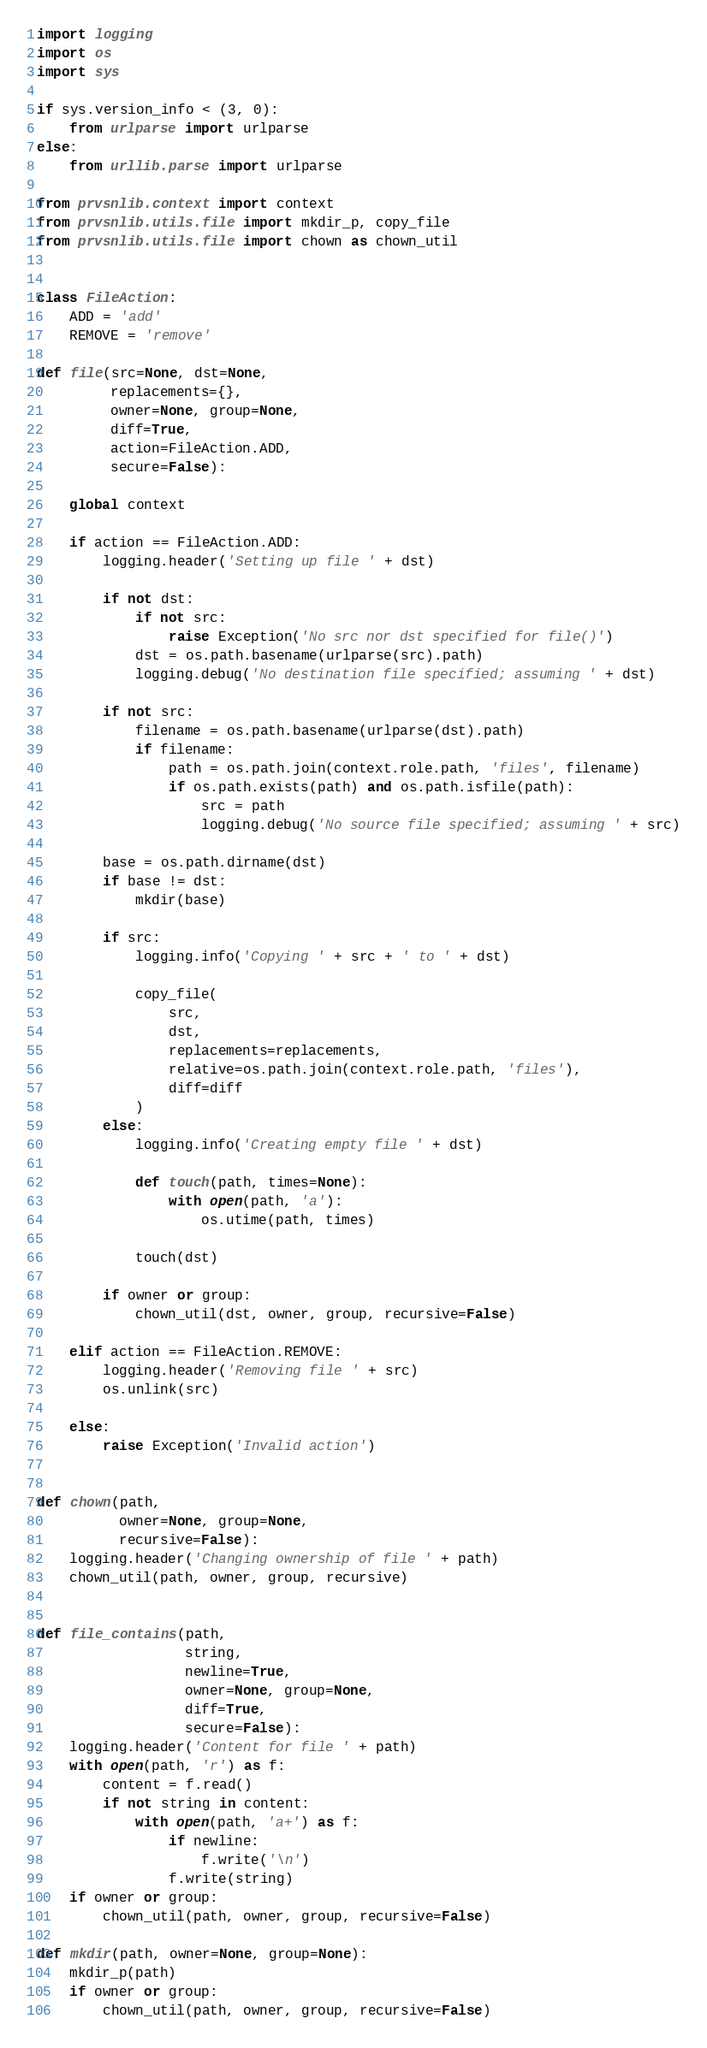Convert code to text. <code><loc_0><loc_0><loc_500><loc_500><_Python_>import logging
import os
import sys

if sys.version_info < (3, 0):
    from urlparse import urlparse
else:
    from urllib.parse import urlparse

from prvsnlib.context import context
from prvsnlib.utils.file import mkdir_p, copy_file
from prvsnlib.utils.file import chown as chown_util


class FileAction:
    ADD = 'add'
    REMOVE = 'remove'

def file(src=None, dst=None,
         replacements={},
         owner=None, group=None,
         diff=True,
         action=FileAction.ADD,
         secure=False):

    global context

    if action == FileAction.ADD:
        logging.header('Setting up file ' + dst)

        if not dst:
            if not src:
                raise Exception('No src nor dst specified for file()')
            dst = os.path.basename(urlparse(src).path)
            logging.debug('No destination file specified; assuming ' + dst)

        if not src:
            filename = os.path.basename(urlparse(dst).path)
            if filename:
                path = os.path.join(context.role.path, 'files', filename)
                if os.path.exists(path) and os.path.isfile(path):
                    src = path
                    logging.debug('No source file specified; assuming ' + src)

        base = os.path.dirname(dst)
        if base != dst:
            mkdir(base)

        if src:
            logging.info('Copying ' + src + ' to ' + dst)

            copy_file(
                src,
                dst,
                replacements=replacements,
                relative=os.path.join(context.role.path, 'files'),
                diff=diff
            )
        else:
            logging.info('Creating empty file ' + dst)

            def touch(path, times=None):
                with open(path, 'a'):
                    os.utime(path, times)

            touch(dst)

        if owner or group:
            chown_util(dst, owner, group, recursive=False)

    elif action == FileAction.REMOVE:
        logging.header('Removing file ' + src)
        os.unlink(src)

    else:
        raise Exception('Invalid action')


def chown(path,
          owner=None, group=None,
          recursive=False):
    logging.header('Changing ownership of file ' + path)
    chown_util(path, owner, group, recursive)


def file_contains(path,
                  string,
                  newline=True,
                  owner=None, group=None,
                  diff=True,
                  secure=False):
    logging.header('Content for file ' + path)
    with open(path, 'r') as f:
        content = f.read()
        if not string in content:
            with open(path, 'a+') as f:
                if newline:
                    f.write('\n')
                f.write(string)
    if owner or group:
        chown_util(path, owner, group, recursive=False)

def mkdir(path, owner=None, group=None):
    mkdir_p(path)
    if owner or group:
        chown_util(path, owner, group, recursive=False)</code> 